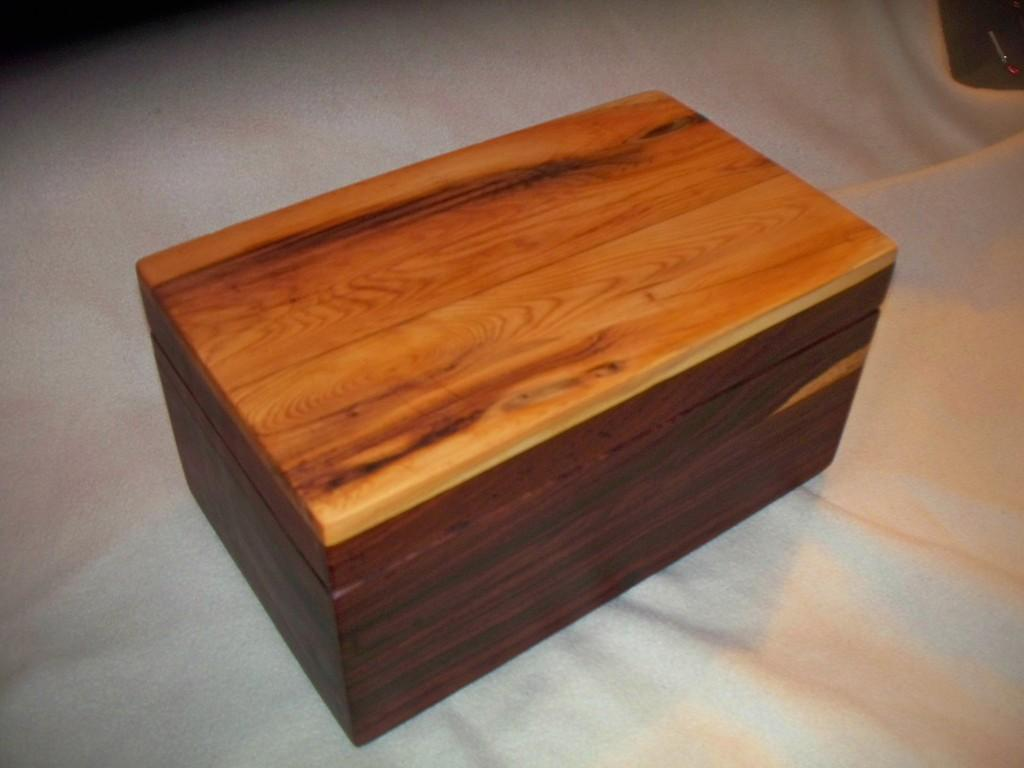What type of object is the main subject of the image? There is a wooden box in the image. What news is being reported by the representative in the image? There is no representative or news present in the image; it only features a wooden box. 